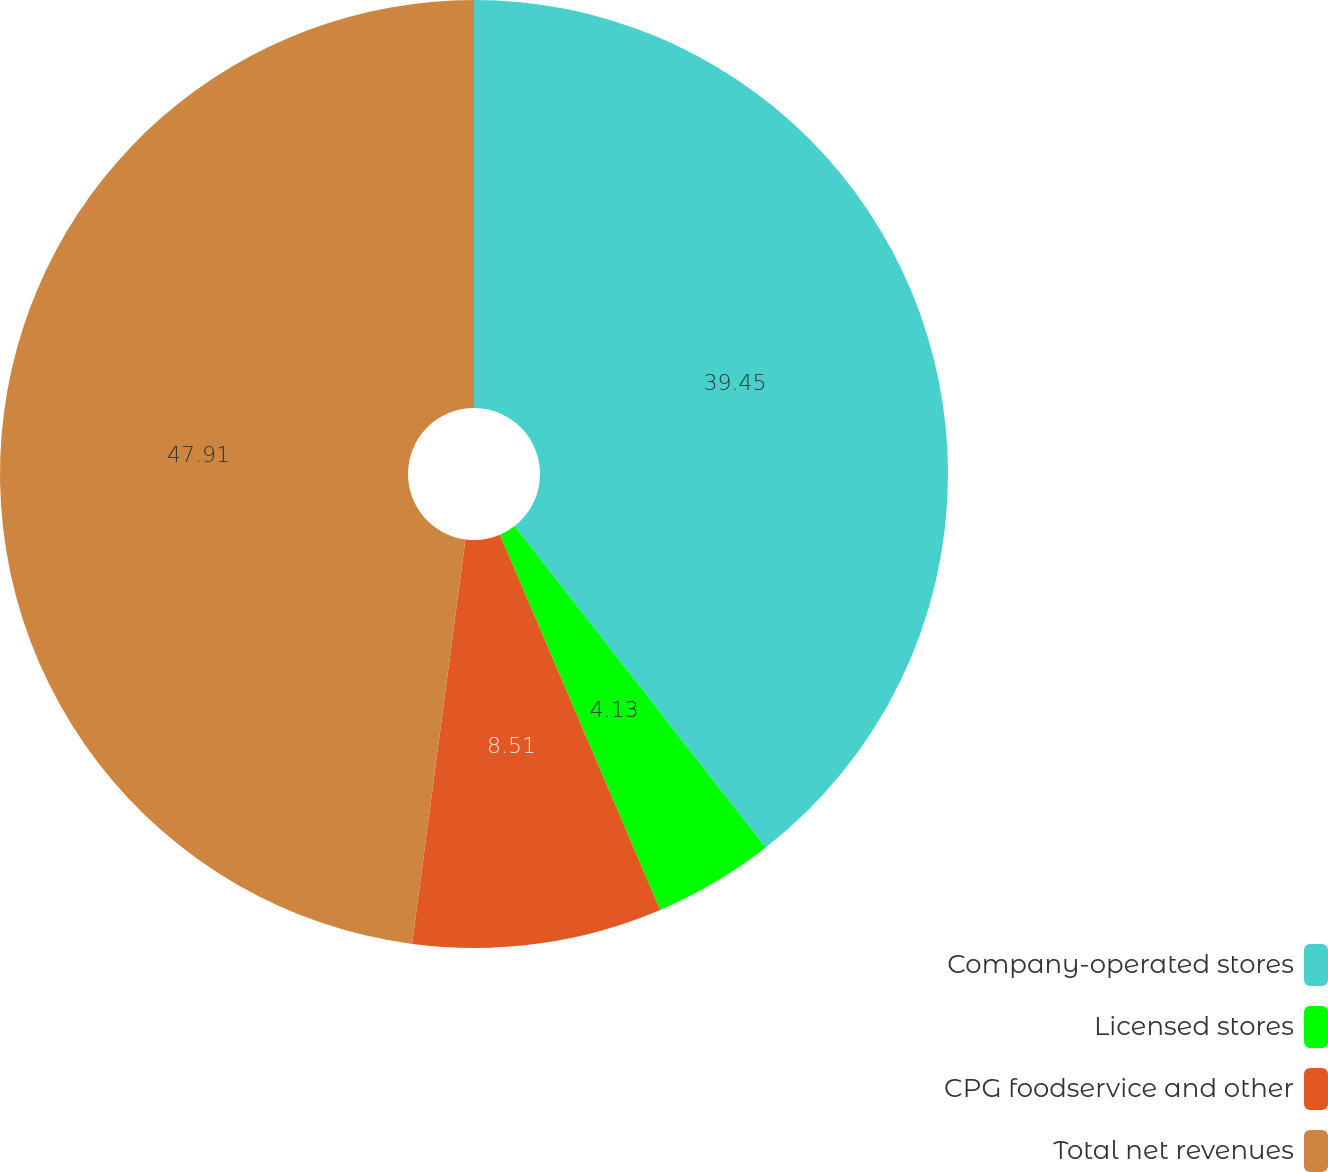Convert chart. <chart><loc_0><loc_0><loc_500><loc_500><pie_chart><fcel>Company-operated stores<fcel>Licensed stores<fcel>CPG foodservice and other<fcel>Total net revenues<nl><fcel>39.45%<fcel>4.13%<fcel>8.51%<fcel>47.92%<nl></chart> 